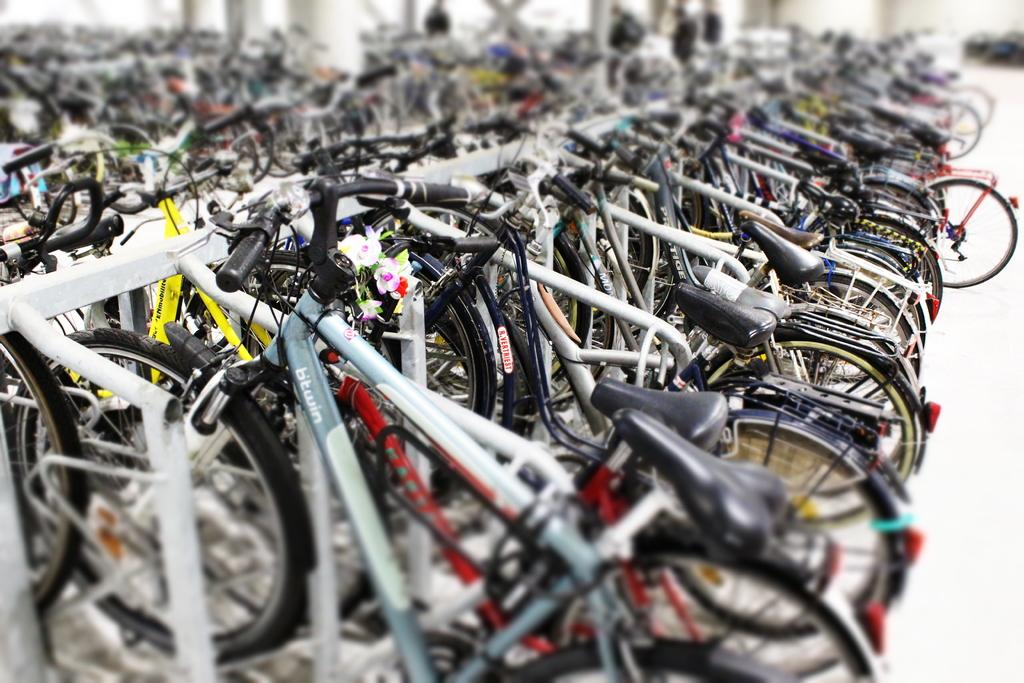What type of vehicles are in the image? There are bicycles in the image. What material are the rods in the image made of? The rods in the image are made of metal. Can you describe the people in the background of the image? There are people in the background of the image, but their specific actions or characteristics are not mentioned in the provided facts. What type of battle is taking place in the image? There is no battle present in the image; it features bicycles and metal rods. What is the authority figure doing in the image? There is no authority figure present in the image. 